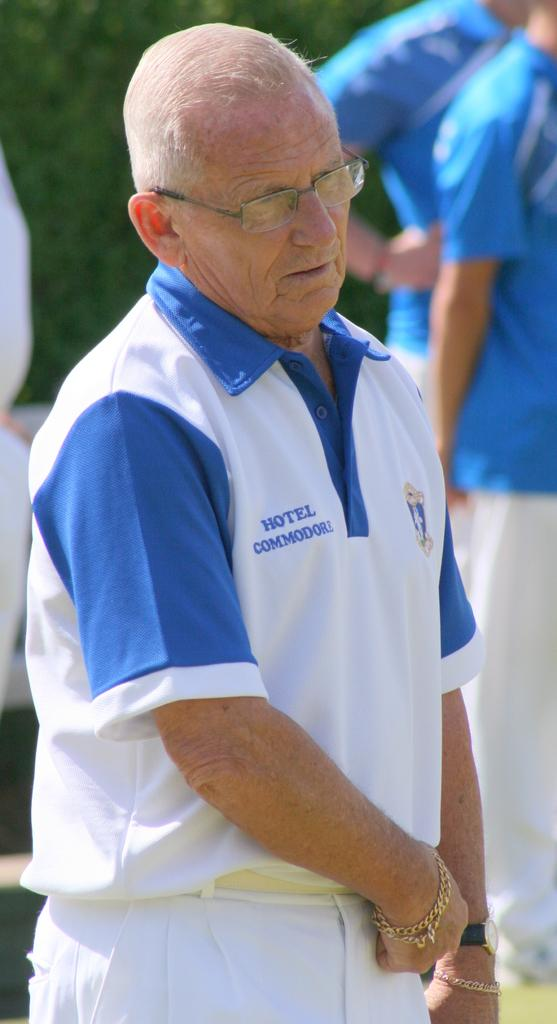Provide a one-sentence caption for the provided image. A old man with white hair is working at Hotel Commodore. 